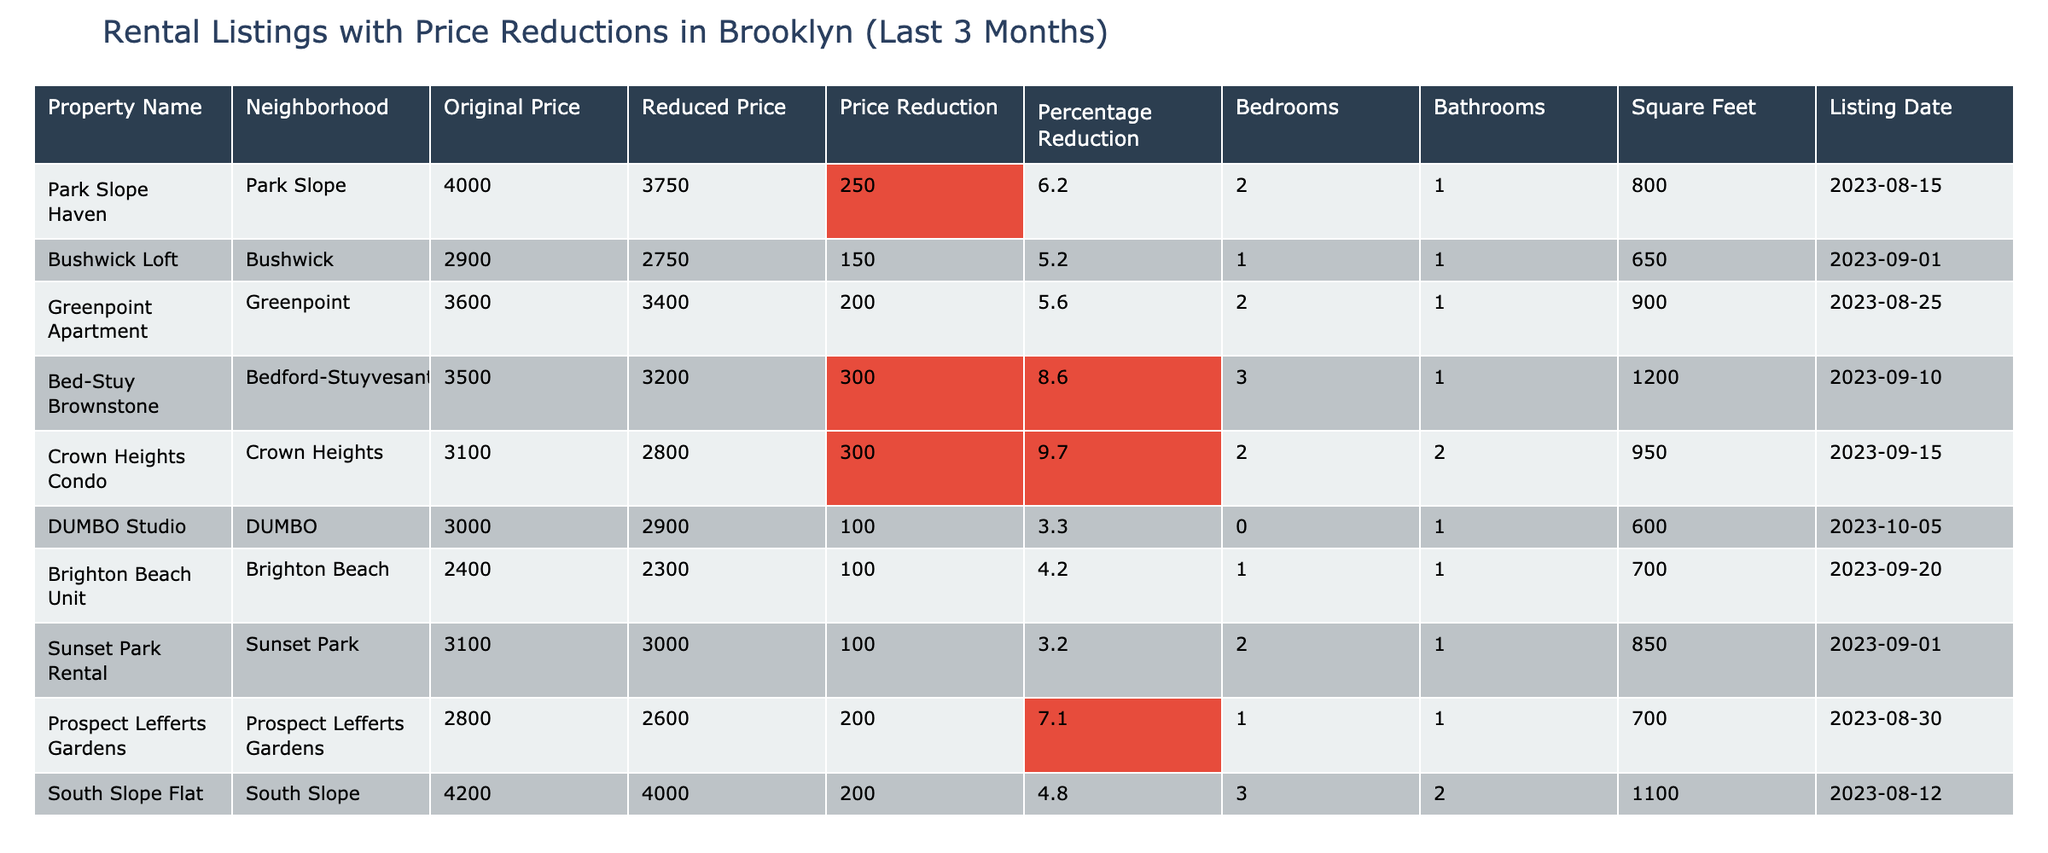What is the reduced price of the "Park Slope Haven"? The reduced price is listed directly next to the property name "Park Slope Haven" in the table. It states the reduced price as 3750.
Answer: 3750 How many bedrooms does the "Bed-Stuy Brownstone" have? The number of bedrooms is specified in the row for "Bed-Stuy Brownstone." Looking at that row, it shows that there are 3 bedrooms.
Answer: 3 What is the price reduction percentage for the "Crown Heights Condo"? To find the percentage reduction, we check the Price Reduction value (300) and the Original Price (3100). The percentage is calculated as (300 / 3100) * 100, which equals approximately 9.7%.
Answer: 9.7% Which property has the largest price reduction? By examining the Price Reduction column, the largest value is 300, found in the rows for "Bed-Stuy Brownstone" and "Crown Heights Condo."
Answer: Bed-Stuy Brownstone and Crown Heights Condo Is there any property that was listed in September that had a price reduction of less than 150? Checking the rows for listings in September, the "Bushwick Loft" reduced its price by 150, and "DUMBO Studio" and "Brighton Beach Unit" reduced their prices by 100, which is less than 150.
Answer: Yes Calculate the total number of bathrooms for all the properties in the table. We sum the Bathrooms column: 1 + 1 + 1 + 1 + 2 + 1 + 1 + 2 + 1 + 2 equals 13.
Answer: 13 What is the average reduced price of properties in the "Bushwick" and "Greenpoint" neighborhoods? The reduced prices for "Bushwick Loft" and "Greenpoint Apartment" are 2750 and 3400. The total is 2750 + 3400 = 6150. Dividing by 2 gives an average of 3075.
Answer: 3075 Which property has the highest original price, and what is that price? Scanning the Original Price column, "South Slope Flat" has the highest original price at 4200.
Answer: 4200 Did any property with a price reduction of at least 250 result in a reduced price of under 3000? "Crown Heights Condo" and "Bed-Stuy Brownstone" both have price reductions of 300, but their reduced prices are above 3000 (2800 for Crown Heights and 3200 for Bed-Stuy). Hence, no property meets both criteria.
Answer: No What is the total square footage of all rentals with a price reduction of 200 or more? The properties with reductions of 200 or more are "Bed-Stuy Brownstone" (1200 sq ft), "Crown Heights Condo" (950 sq ft), "Greenpoint Apartment" (900 sq ft), "Prospect Lefferts Gardens" (700 sq ft), and "South Slope Flat" (1100 sq ft). Summing them gives 1200 + 950 + 900 + 700 + 1100 = 3850 sq ft.
Answer: 3850 sq ft 